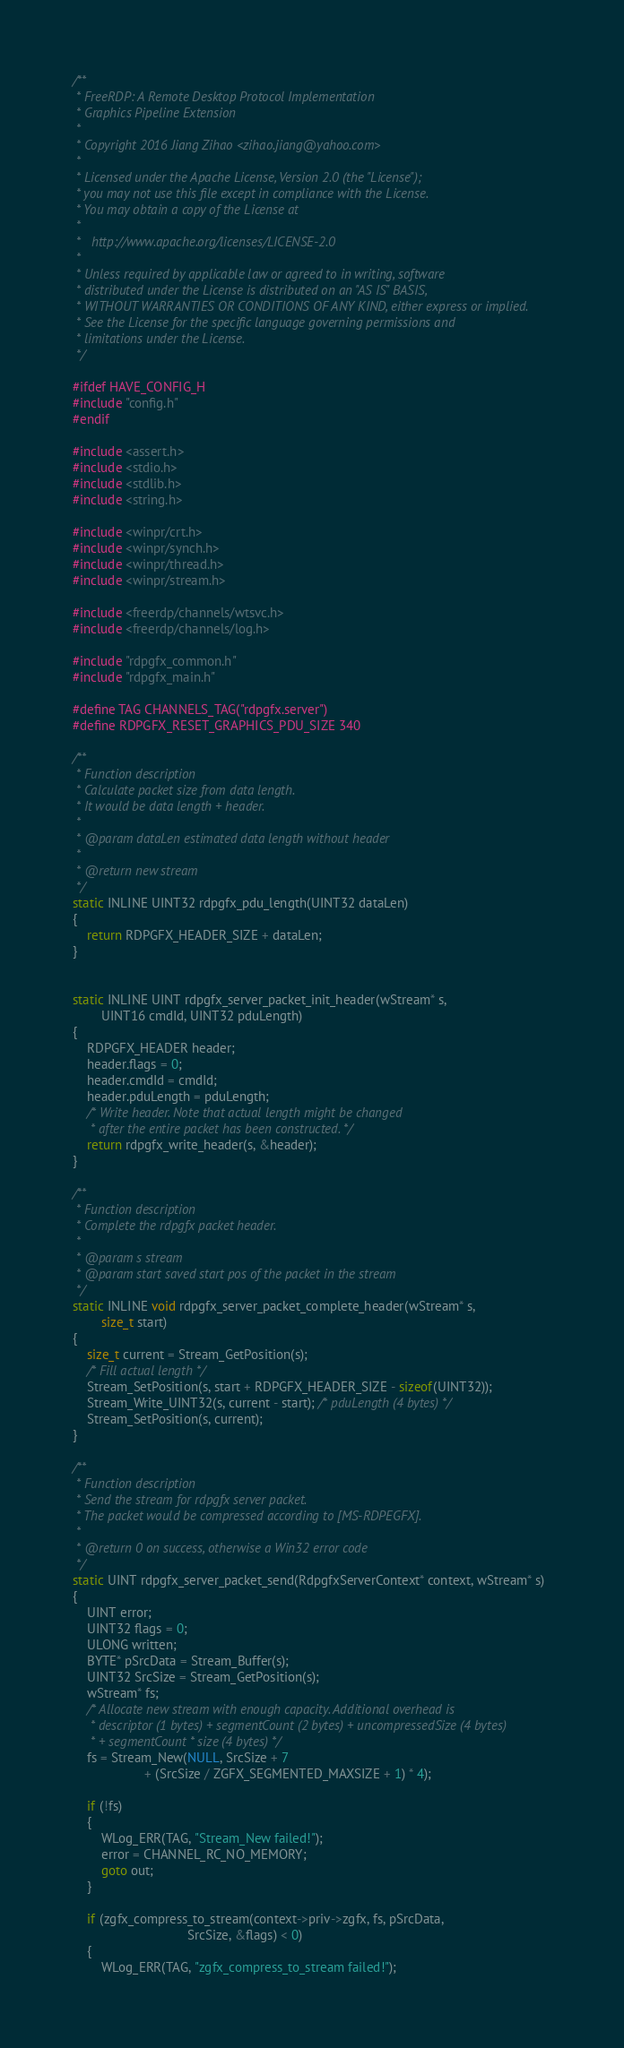Convert code to text. <code><loc_0><loc_0><loc_500><loc_500><_C_>/**
 * FreeRDP: A Remote Desktop Protocol Implementation
 * Graphics Pipeline Extension
 *
 * Copyright 2016 Jiang Zihao <zihao.jiang@yahoo.com>
 *
 * Licensed under the Apache License, Version 2.0 (the "License");
 * you may not use this file except in compliance with the License.
 * You may obtain a copy of the License at
 *
 *	 http://www.apache.org/licenses/LICENSE-2.0
 *
 * Unless required by applicable law or agreed to in writing, software
 * distributed under the License is distributed on an "AS IS" BASIS,
 * WITHOUT WARRANTIES OR CONDITIONS OF ANY KIND, either express or implied.
 * See the License for the specific language governing permissions and
 * limitations under the License.
 */

#ifdef HAVE_CONFIG_H
#include "config.h"
#endif

#include <assert.h>
#include <stdio.h>
#include <stdlib.h>
#include <string.h>

#include <winpr/crt.h>
#include <winpr/synch.h>
#include <winpr/thread.h>
#include <winpr/stream.h>

#include <freerdp/channels/wtsvc.h>
#include <freerdp/channels/log.h>

#include "rdpgfx_common.h"
#include "rdpgfx_main.h"

#define TAG CHANNELS_TAG("rdpgfx.server")
#define RDPGFX_RESET_GRAPHICS_PDU_SIZE 340

/**
 * Function description
 * Calculate packet size from data length.
 * It would be data length + header.
 *
 * @param dataLen estimated data length without header
 *
 * @return new stream
 */
static INLINE UINT32 rdpgfx_pdu_length(UINT32 dataLen)
{
	return RDPGFX_HEADER_SIZE + dataLen;
}


static INLINE UINT rdpgfx_server_packet_init_header(wStream* s,
        UINT16 cmdId, UINT32 pduLength)
{
	RDPGFX_HEADER header;
	header.flags = 0;
	header.cmdId = cmdId;
	header.pduLength = pduLength;
	/* Write header. Note that actual length might be changed
	 * after the entire packet has been constructed. */
	return rdpgfx_write_header(s, &header);
}

/**
 * Function description
 * Complete the rdpgfx packet header.
 *
 * @param s stream
 * @param start saved start pos of the packet in the stream
 */
static INLINE void rdpgfx_server_packet_complete_header(wStream* s,
        size_t start)
{
	size_t current = Stream_GetPosition(s);
	/* Fill actual length */
	Stream_SetPosition(s, start + RDPGFX_HEADER_SIZE - sizeof(UINT32));
	Stream_Write_UINT32(s, current - start); /* pduLength (4 bytes) */
	Stream_SetPosition(s, current);
}

/**
 * Function description
 * Send the stream for rdpgfx server packet.
 * The packet would be compressed according to [MS-RDPEGFX].
 *
 * @return 0 on success, otherwise a Win32 error code
 */
static UINT rdpgfx_server_packet_send(RdpgfxServerContext* context, wStream* s)
{
	UINT error;
	UINT32 flags = 0;
	ULONG written;
	BYTE* pSrcData = Stream_Buffer(s);
	UINT32 SrcSize = Stream_GetPosition(s);
	wStream* fs;
	/* Allocate new stream with enough capacity. Additional overhead is
	 * descriptor (1 bytes) + segmentCount (2 bytes) + uncompressedSize (4 bytes)
	 * + segmentCount * size (4 bytes) */
	fs = Stream_New(NULL, SrcSize + 7
	                + (SrcSize / ZGFX_SEGMENTED_MAXSIZE + 1) * 4);

	if (!fs)
	{
		WLog_ERR(TAG, "Stream_New failed!");
		error = CHANNEL_RC_NO_MEMORY;
		goto out;
	}

	if (zgfx_compress_to_stream(context->priv->zgfx, fs, pSrcData,
	                            SrcSize, &flags) < 0)
	{
		WLog_ERR(TAG, "zgfx_compress_to_stream failed!");</code> 